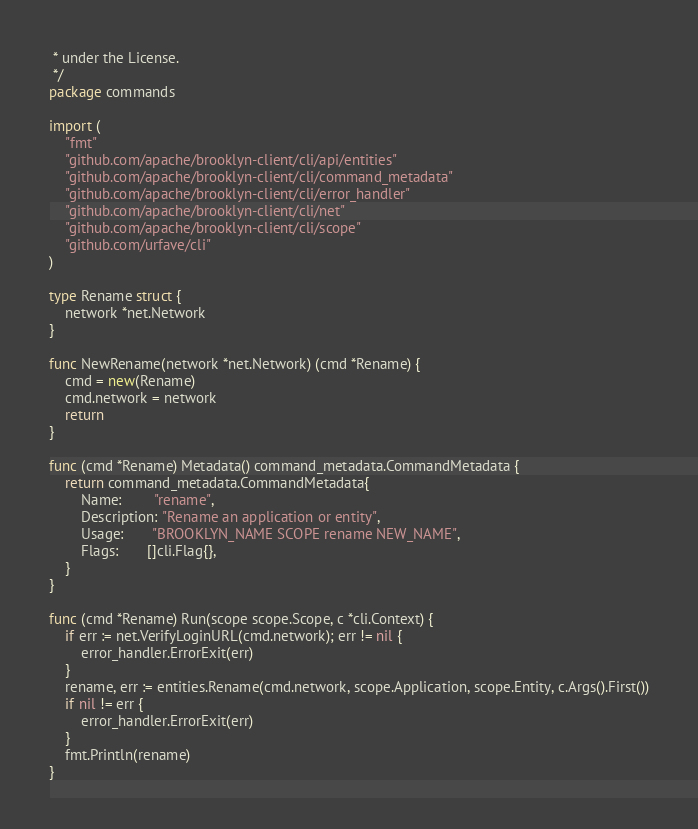<code> <loc_0><loc_0><loc_500><loc_500><_Go_> * under the License.
 */
package commands

import (
	"fmt"
	"github.com/apache/brooklyn-client/cli/api/entities"
	"github.com/apache/brooklyn-client/cli/command_metadata"
	"github.com/apache/brooklyn-client/cli/error_handler"
	"github.com/apache/brooklyn-client/cli/net"
	"github.com/apache/brooklyn-client/cli/scope"
	"github.com/urfave/cli"
)

type Rename struct {
	network *net.Network
}

func NewRename(network *net.Network) (cmd *Rename) {
	cmd = new(Rename)
	cmd.network = network
	return
}

func (cmd *Rename) Metadata() command_metadata.CommandMetadata {
	return command_metadata.CommandMetadata{
		Name:        "rename",
		Description: "Rename an application or entity",
		Usage:       "BROOKLYN_NAME SCOPE rename NEW_NAME",
		Flags:       []cli.Flag{},
	}
}

func (cmd *Rename) Run(scope scope.Scope, c *cli.Context) {
	if err := net.VerifyLoginURL(cmd.network); err != nil {
		error_handler.ErrorExit(err)
	}
	rename, err := entities.Rename(cmd.network, scope.Application, scope.Entity, c.Args().First())
	if nil != err {
		error_handler.ErrorExit(err)
	}
	fmt.Println(rename)
}
</code> 